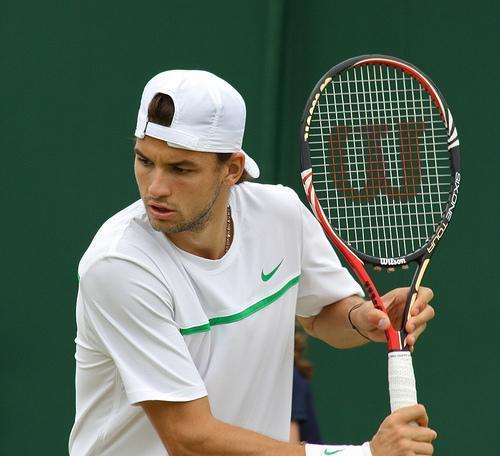How many players are in the picture?
Give a very brief answer. 1. 